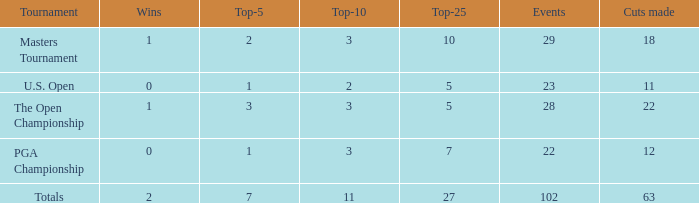How many cuts made for a player with 2 victories and fewer than 7 top 5s? None. 